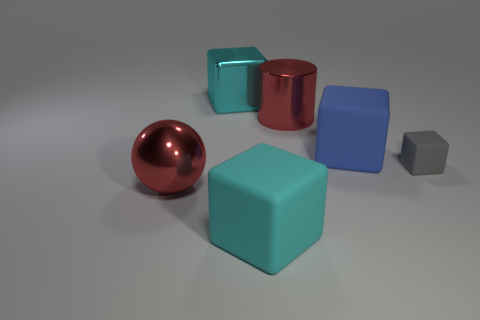Subtract all brown cubes. Subtract all yellow cylinders. How many cubes are left? 4 Add 2 large purple matte blocks. How many objects exist? 8 Subtract all cubes. How many objects are left? 2 Add 6 balls. How many balls are left? 7 Add 3 things. How many things exist? 9 Subtract 0 brown balls. How many objects are left? 6 Subtract all big spheres. Subtract all large metallic cylinders. How many objects are left? 4 